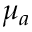<formula> <loc_0><loc_0><loc_500><loc_500>\mu _ { a }</formula> 